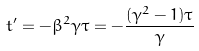<formula> <loc_0><loc_0><loc_500><loc_500>t ^ { \prime } = - \beta ^ { 2 } \gamma \tau = - \frac { ( \gamma ^ { 2 } - 1 ) \tau } { \gamma }</formula> 